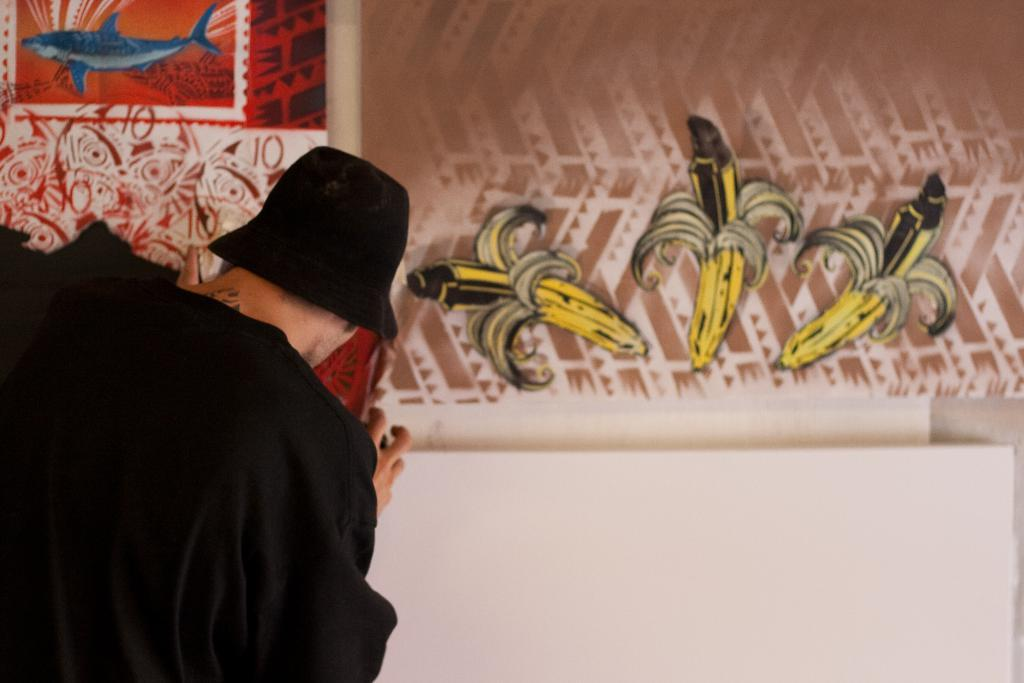Who is the main subject in the image? There is a person in the center of the image. What is the person wearing on their upper body? The person is wearing a black shirt. What type of headwear is the person wearing? The person is wearing a black hat. What can be seen in the background of the image? There are paintings in the background of the image. What type of mountain can be seen in the background of the image? There are no mountains present in the image; it features a person wearing a black shirt and hat with paintings in the background. 